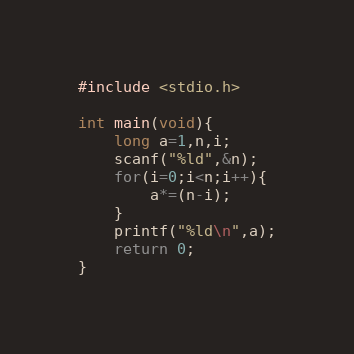Convert code to text. <code><loc_0><loc_0><loc_500><loc_500><_C_>#include <stdio.h>

int main(void){
    long a=1,n,i;
    scanf("%ld",&n);
    for(i=0;i<n;i++){
        a*=(n-i);
    }
    printf("%ld\n",a);
    return 0;
}</code> 